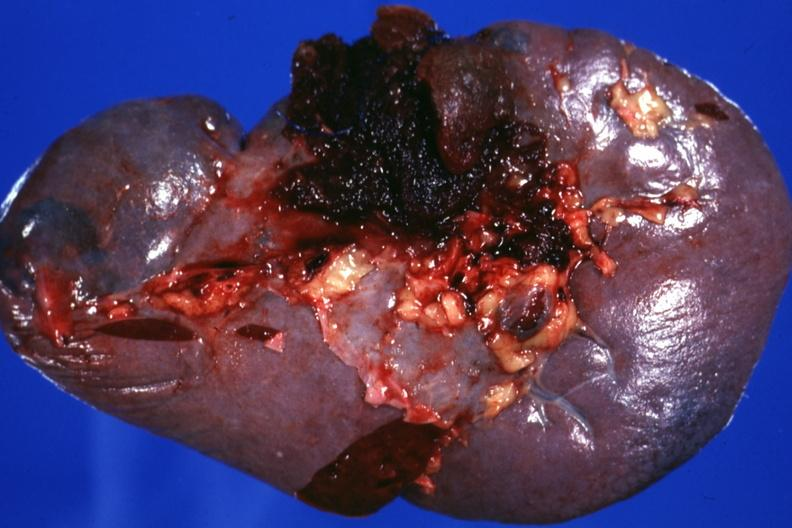s hematologic present?
Answer the question using a single word or phrase. Yes 